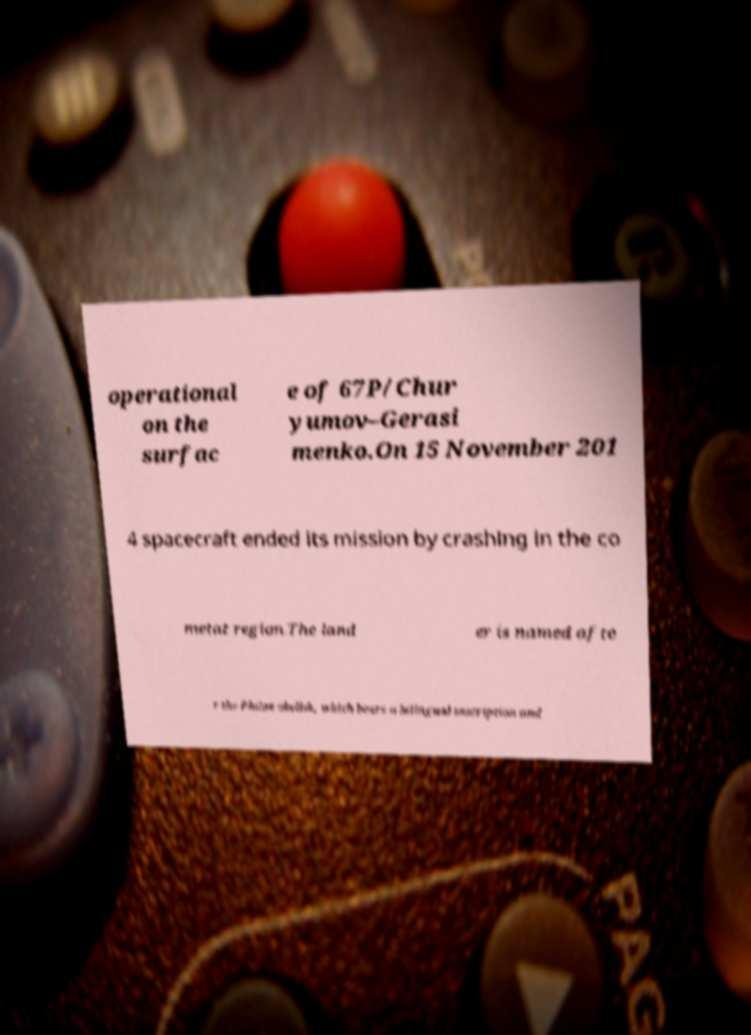Can you accurately transcribe the text from the provided image for me? operational on the surfac e of 67P/Chur yumov–Gerasi menko.On 15 November 201 4 spacecraft ended its mission by crashing in the co metat region.The land er is named afte r the Philae obelisk, which bears a bilingual inscription and 